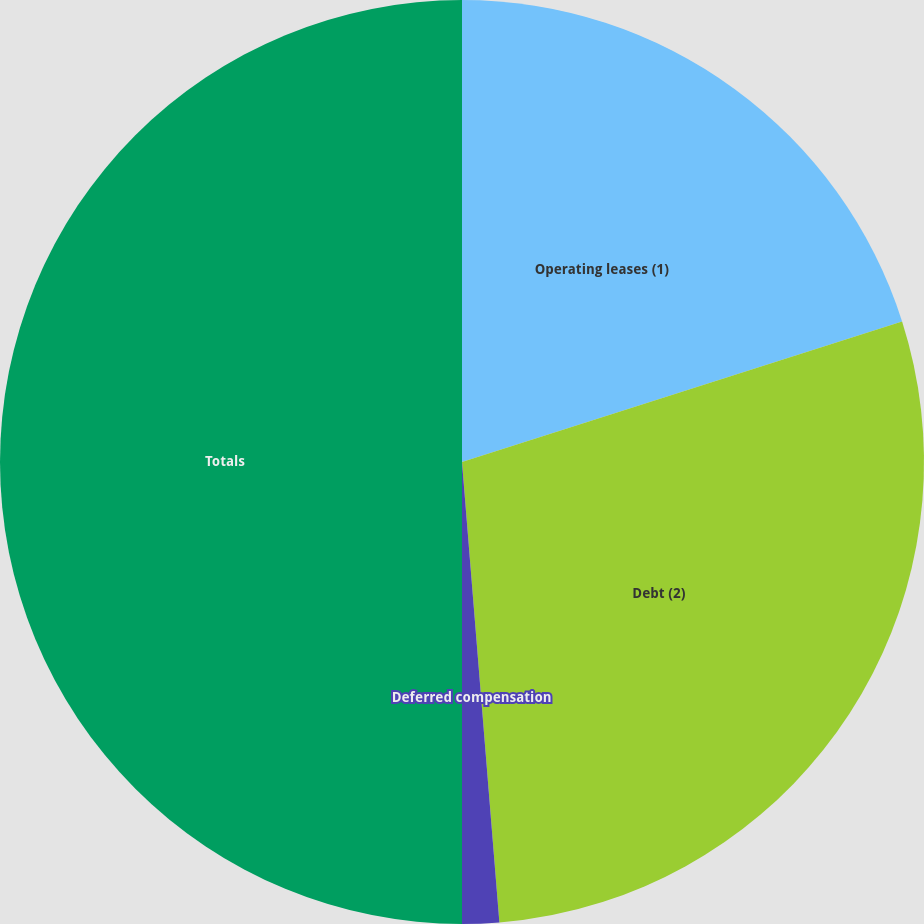Convert chart. <chart><loc_0><loc_0><loc_500><loc_500><pie_chart><fcel>Operating leases (1)<fcel>Debt (2)<fcel>Deferred compensation<fcel>Totals<nl><fcel>20.08%<fcel>28.63%<fcel>1.29%<fcel>50.0%<nl></chart> 